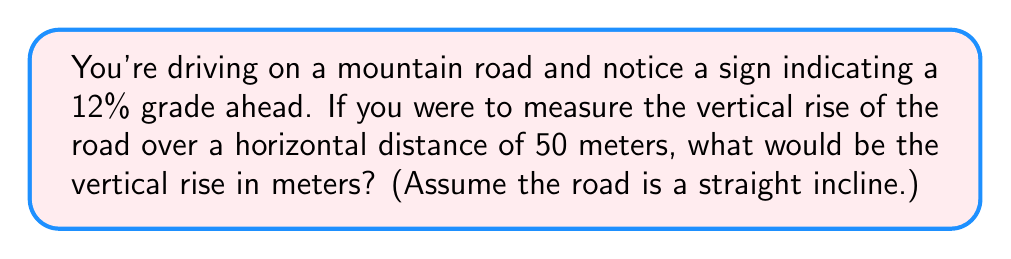Solve this math problem. Let's approach this step-by-step:

1) First, we need to understand what a 12% grade means. In road design, the grade percentage is the ratio of vertical rise to horizontal distance, expressed as a percentage.

2) Mathematically, this can be expressed as:

   $$ \text{Grade (%)} = \frac{\text{Vertical Rise}}{\text{Horizontal Distance}} \times 100\% $$

3) We're given a 12% grade and a horizontal distance of 50 meters. Let's call the vertical rise $y$. We can set up the equation:

   $$ 12\% = \frac{y}{50 \text{ m}} \times 100\% $$

4) To solve for $y$, first divide both sides by 100%:

   $$ 0.12 = \frac{y}{50 \text{ m}} $$

5) Now multiply both sides by 50 m:

   $$ y = 0.12 \times 50 \text{ m} = 6 \text{ m} $$

6) Therefore, the vertical rise over a 50 meter horizontal distance on a 12% grade is 6 meters.

This problem relates to safe driving conditions because understanding road grades is crucial for maintaining control of a vehicle, especially in challenging weather conditions or when driving larger vehicles like trucks.

[asy]
import geometry;

size(200);
pair A=(0,0), B=(100,0), C=(100,12);
draw(A--B--C--A);
label("50 m", (50,0), S);
label("6 m", (100,6), E);
label("12% grade", (50,8), NW);
draw((95,0)--(100,0)--(100,5), Arrow);
[/asy]
Answer: The vertical rise is 6 meters. 